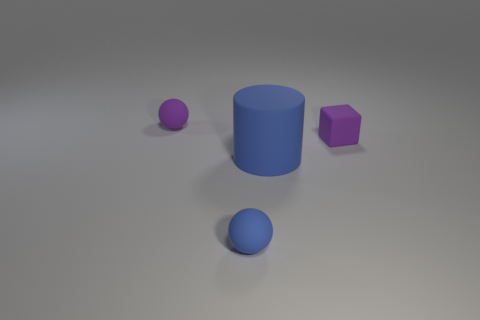Is there anything else that has the same size as the purple matte block?
Provide a succinct answer. Yes. There is a small block right of the blue matte cylinder to the left of the small rubber cube; what is its color?
Give a very brief answer. Purple. How many objects are either blue matte cylinders or blue things behind the tiny blue ball?
Provide a succinct answer. 1. What is the color of the small rubber object to the right of the small blue object?
Keep it short and to the point. Purple. The big blue object is what shape?
Ensure brevity in your answer.  Cylinder. What material is the sphere that is behind the tiny purple object on the right side of the purple sphere made of?
Ensure brevity in your answer.  Rubber. How many other objects are the same material as the large blue thing?
Provide a succinct answer. 3. There is a blue ball that is the same size as the purple block; what is its material?
Ensure brevity in your answer.  Rubber. Is the number of tiny cubes that are on the left side of the matte cube greater than the number of big blue matte things in front of the large rubber cylinder?
Make the answer very short. No. Is there a small purple object of the same shape as the tiny blue rubber object?
Make the answer very short. Yes. 